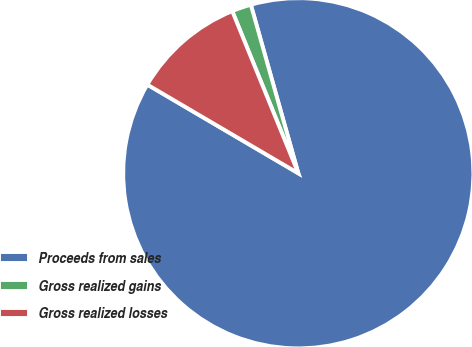Convert chart. <chart><loc_0><loc_0><loc_500><loc_500><pie_chart><fcel>Proceeds from sales<fcel>Gross realized gains<fcel>Gross realized losses<nl><fcel>87.81%<fcel>1.79%<fcel>10.39%<nl></chart> 